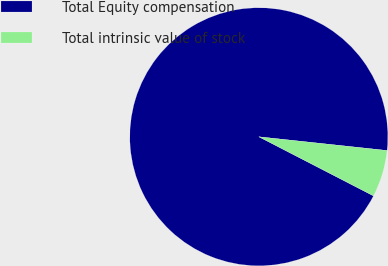Convert chart. <chart><loc_0><loc_0><loc_500><loc_500><pie_chart><fcel>Total Equity compensation<fcel>Total intrinsic value of stock<nl><fcel>94.12%<fcel>5.88%<nl></chart> 